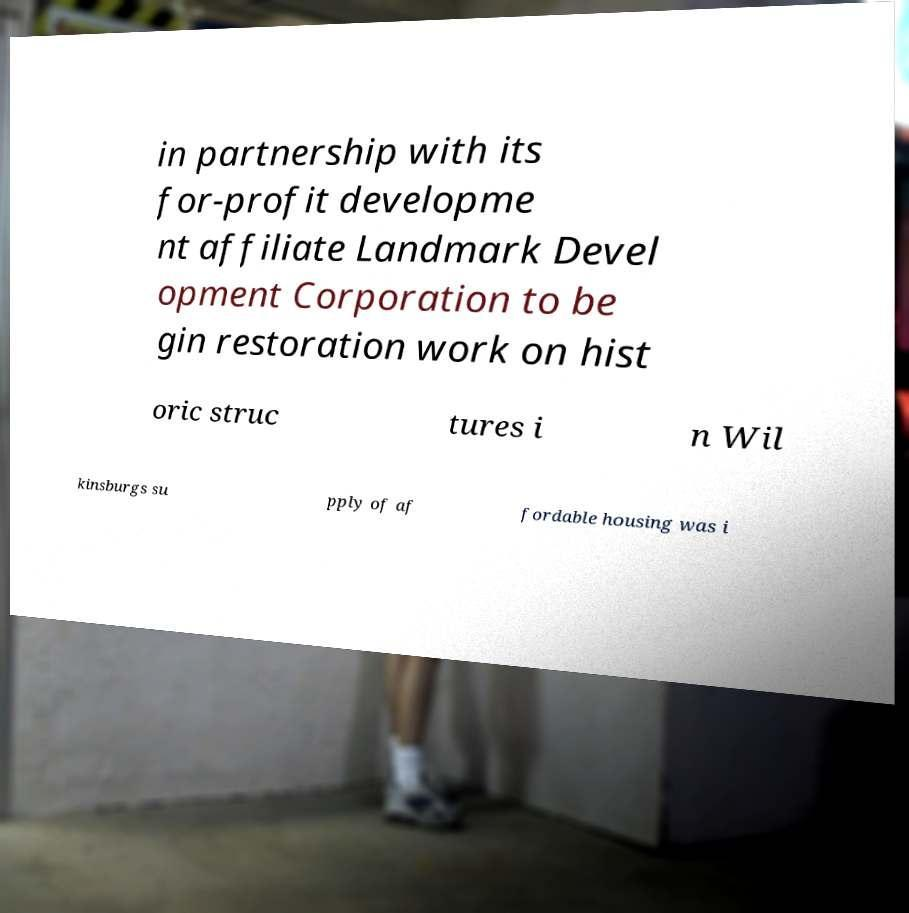Please read and relay the text visible in this image. What does it say? in partnership with its for-profit developme nt affiliate Landmark Devel opment Corporation to be gin restoration work on hist oric struc tures i n Wil kinsburgs su pply of af fordable housing was i 